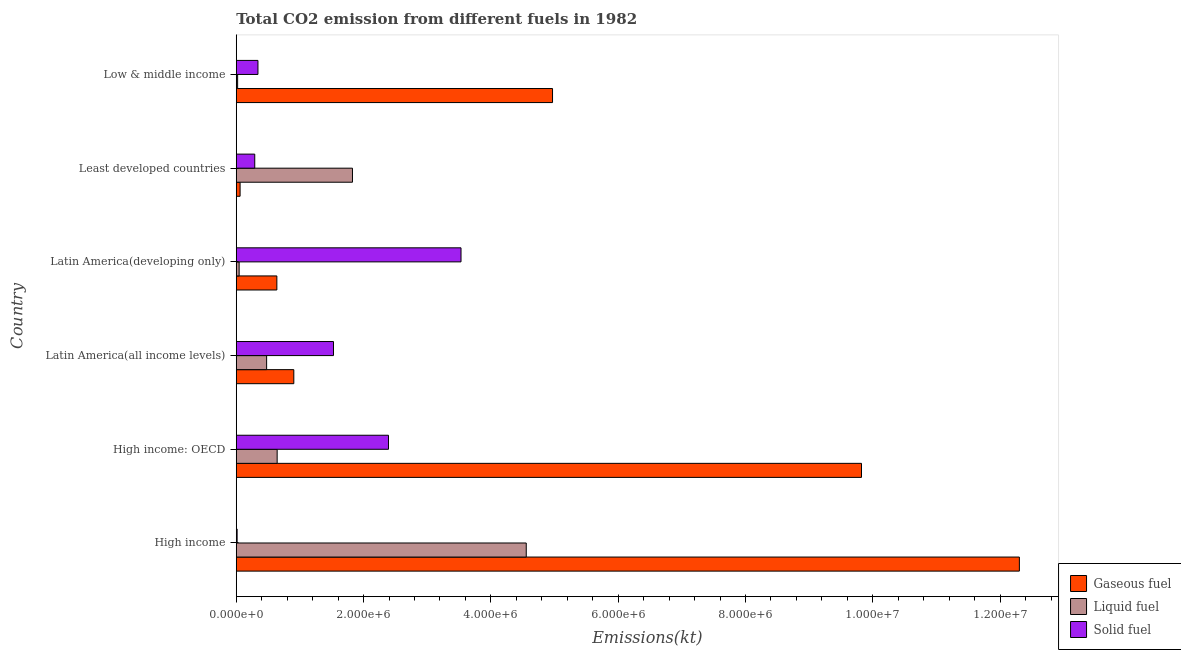How many different coloured bars are there?
Ensure brevity in your answer.  3. Are the number of bars per tick equal to the number of legend labels?
Provide a short and direct response. Yes. What is the label of the 4th group of bars from the top?
Ensure brevity in your answer.  Latin America(all income levels). In how many cases, is the number of bars for a given country not equal to the number of legend labels?
Keep it short and to the point. 0. What is the amount of co2 emissions from liquid fuel in High income: OECD?
Your answer should be very brief. 6.43e+05. Across all countries, what is the maximum amount of co2 emissions from liquid fuel?
Offer a very short reply. 4.56e+06. Across all countries, what is the minimum amount of co2 emissions from liquid fuel?
Offer a terse response. 2.16e+04. In which country was the amount of co2 emissions from solid fuel maximum?
Ensure brevity in your answer.  Latin America(developing only). In which country was the amount of co2 emissions from gaseous fuel minimum?
Give a very brief answer. Least developed countries. What is the total amount of co2 emissions from gaseous fuel in the graph?
Offer a very short reply. 2.87e+07. What is the difference between the amount of co2 emissions from liquid fuel in High income and that in High income: OECD?
Make the answer very short. 3.91e+06. What is the difference between the amount of co2 emissions from gaseous fuel in Least developed countries and the amount of co2 emissions from solid fuel in High income: OECD?
Offer a very short reply. -2.33e+06. What is the average amount of co2 emissions from solid fuel per country?
Your answer should be very brief. 1.35e+06. What is the difference between the amount of co2 emissions from gaseous fuel and amount of co2 emissions from solid fuel in Latin America(all income levels)?
Provide a succinct answer. -6.23e+05. In how many countries, is the amount of co2 emissions from solid fuel greater than 12000000 kt?
Your response must be concise. 0. What is the ratio of the amount of co2 emissions from gaseous fuel in High income: OECD to that in Latin America(all income levels)?
Keep it short and to the point. 10.86. Is the difference between the amount of co2 emissions from gaseous fuel in High income and Latin America(developing only) greater than the difference between the amount of co2 emissions from liquid fuel in High income and Latin America(developing only)?
Your answer should be very brief. Yes. What is the difference between the highest and the second highest amount of co2 emissions from gaseous fuel?
Offer a terse response. 2.48e+06. What is the difference between the highest and the lowest amount of co2 emissions from liquid fuel?
Give a very brief answer. 4.53e+06. Is the sum of the amount of co2 emissions from solid fuel in High income and Latin America(all income levels) greater than the maximum amount of co2 emissions from liquid fuel across all countries?
Ensure brevity in your answer.  No. What does the 1st bar from the top in Latin America(developing only) represents?
Provide a succinct answer. Solid fuel. What does the 3rd bar from the bottom in Low & middle income represents?
Your answer should be compact. Solid fuel. Is it the case that in every country, the sum of the amount of co2 emissions from gaseous fuel and amount of co2 emissions from liquid fuel is greater than the amount of co2 emissions from solid fuel?
Your answer should be very brief. No. What is the difference between two consecutive major ticks on the X-axis?
Make the answer very short. 2.00e+06. Where does the legend appear in the graph?
Provide a succinct answer. Bottom right. How many legend labels are there?
Your answer should be compact. 3. How are the legend labels stacked?
Offer a terse response. Vertical. What is the title of the graph?
Your response must be concise. Total CO2 emission from different fuels in 1982. Does "Interest" appear as one of the legend labels in the graph?
Your answer should be compact. No. What is the label or title of the X-axis?
Ensure brevity in your answer.  Emissions(kt). What is the label or title of the Y-axis?
Your answer should be very brief. Country. What is the Emissions(kt) in Gaseous fuel in High income?
Offer a terse response. 1.23e+07. What is the Emissions(kt) in Liquid fuel in High income?
Keep it short and to the point. 4.56e+06. What is the Emissions(kt) of Solid fuel in High income?
Give a very brief answer. 1.37e+04. What is the Emissions(kt) of Gaseous fuel in High income: OECD?
Offer a terse response. 9.82e+06. What is the Emissions(kt) in Liquid fuel in High income: OECD?
Ensure brevity in your answer.  6.43e+05. What is the Emissions(kt) in Solid fuel in High income: OECD?
Offer a very short reply. 2.39e+06. What is the Emissions(kt) of Gaseous fuel in Latin America(all income levels)?
Keep it short and to the point. 9.04e+05. What is the Emissions(kt) of Liquid fuel in Latin America(all income levels)?
Give a very brief answer. 4.77e+05. What is the Emissions(kt) in Solid fuel in Latin America(all income levels)?
Your answer should be compact. 1.53e+06. What is the Emissions(kt) of Gaseous fuel in Latin America(developing only)?
Your answer should be compact. 6.38e+05. What is the Emissions(kt) of Liquid fuel in Latin America(developing only)?
Give a very brief answer. 4.53e+04. What is the Emissions(kt) of Solid fuel in Latin America(developing only)?
Provide a short and direct response. 3.53e+06. What is the Emissions(kt) in Gaseous fuel in Least developed countries?
Offer a very short reply. 6.04e+04. What is the Emissions(kt) of Liquid fuel in Least developed countries?
Provide a succinct answer. 1.83e+06. What is the Emissions(kt) in Solid fuel in Least developed countries?
Make the answer very short. 2.91e+05. What is the Emissions(kt) in Gaseous fuel in Low & middle income?
Provide a short and direct response. 4.97e+06. What is the Emissions(kt) in Liquid fuel in Low & middle income?
Keep it short and to the point. 2.16e+04. What is the Emissions(kt) of Solid fuel in Low & middle income?
Offer a very short reply. 3.41e+05. Across all countries, what is the maximum Emissions(kt) in Gaseous fuel?
Keep it short and to the point. 1.23e+07. Across all countries, what is the maximum Emissions(kt) of Liquid fuel?
Offer a very short reply. 4.56e+06. Across all countries, what is the maximum Emissions(kt) of Solid fuel?
Your response must be concise. 3.53e+06. Across all countries, what is the minimum Emissions(kt) in Gaseous fuel?
Provide a succinct answer. 6.04e+04. Across all countries, what is the minimum Emissions(kt) in Liquid fuel?
Offer a terse response. 2.16e+04. Across all countries, what is the minimum Emissions(kt) in Solid fuel?
Your response must be concise. 1.37e+04. What is the total Emissions(kt) in Gaseous fuel in the graph?
Your answer should be very brief. 2.87e+07. What is the total Emissions(kt) of Liquid fuel in the graph?
Your response must be concise. 7.57e+06. What is the total Emissions(kt) in Solid fuel in the graph?
Give a very brief answer. 8.10e+06. What is the difference between the Emissions(kt) of Gaseous fuel in High income and that in High income: OECD?
Provide a short and direct response. 2.48e+06. What is the difference between the Emissions(kt) of Liquid fuel in High income and that in High income: OECD?
Provide a short and direct response. 3.91e+06. What is the difference between the Emissions(kt) of Solid fuel in High income and that in High income: OECD?
Make the answer very short. -2.38e+06. What is the difference between the Emissions(kt) of Gaseous fuel in High income and that in Latin America(all income levels)?
Ensure brevity in your answer.  1.14e+07. What is the difference between the Emissions(kt) in Liquid fuel in High income and that in Latin America(all income levels)?
Provide a short and direct response. 4.08e+06. What is the difference between the Emissions(kt) of Solid fuel in High income and that in Latin America(all income levels)?
Provide a short and direct response. -1.51e+06. What is the difference between the Emissions(kt) in Gaseous fuel in High income and that in Latin America(developing only)?
Keep it short and to the point. 1.17e+07. What is the difference between the Emissions(kt) in Liquid fuel in High income and that in Latin America(developing only)?
Your response must be concise. 4.51e+06. What is the difference between the Emissions(kt) of Solid fuel in High income and that in Latin America(developing only)?
Make the answer very short. -3.52e+06. What is the difference between the Emissions(kt) of Gaseous fuel in High income and that in Least developed countries?
Ensure brevity in your answer.  1.22e+07. What is the difference between the Emissions(kt) of Liquid fuel in High income and that in Least developed countries?
Offer a very short reply. 2.73e+06. What is the difference between the Emissions(kt) in Solid fuel in High income and that in Least developed countries?
Offer a very short reply. -2.77e+05. What is the difference between the Emissions(kt) of Gaseous fuel in High income and that in Low & middle income?
Offer a terse response. 7.33e+06. What is the difference between the Emissions(kt) of Liquid fuel in High income and that in Low & middle income?
Make the answer very short. 4.53e+06. What is the difference between the Emissions(kt) in Solid fuel in High income and that in Low & middle income?
Your answer should be compact. -3.27e+05. What is the difference between the Emissions(kt) of Gaseous fuel in High income: OECD and that in Latin America(all income levels)?
Provide a short and direct response. 8.92e+06. What is the difference between the Emissions(kt) of Liquid fuel in High income: OECD and that in Latin America(all income levels)?
Give a very brief answer. 1.65e+05. What is the difference between the Emissions(kt) in Solid fuel in High income: OECD and that in Latin America(all income levels)?
Provide a succinct answer. 8.64e+05. What is the difference between the Emissions(kt) of Gaseous fuel in High income: OECD and that in Latin America(developing only)?
Offer a terse response. 9.18e+06. What is the difference between the Emissions(kt) in Liquid fuel in High income: OECD and that in Latin America(developing only)?
Keep it short and to the point. 5.97e+05. What is the difference between the Emissions(kt) of Solid fuel in High income: OECD and that in Latin America(developing only)?
Keep it short and to the point. -1.14e+06. What is the difference between the Emissions(kt) in Gaseous fuel in High income: OECD and that in Least developed countries?
Your answer should be very brief. 9.76e+06. What is the difference between the Emissions(kt) in Liquid fuel in High income: OECD and that in Least developed countries?
Provide a succinct answer. -1.18e+06. What is the difference between the Emissions(kt) of Solid fuel in High income: OECD and that in Least developed countries?
Your answer should be compact. 2.10e+06. What is the difference between the Emissions(kt) in Gaseous fuel in High income: OECD and that in Low & middle income?
Your answer should be very brief. 4.85e+06. What is the difference between the Emissions(kt) of Liquid fuel in High income: OECD and that in Low & middle income?
Offer a terse response. 6.21e+05. What is the difference between the Emissions(kt) in Solid fuel in High income: OECD and that in Low & middle income?
Provide a succinct answer. 2.05e+06. What is the difference between the Emissions(kt) in Gaseous fuel in Latin America(all income levels) and that in Latin America(developing only)?
Provide a succinct answer. 2.66e+05. What is the difference between the Emissions(kt) of Liquid fuel in Latin America(all income levels) and that in Latin America(developing only)?
Give a very brief answer. 4.32e+05. What is the difference between the Emissions(kt) in Solid fuel in Latin America(all income levels) and that in Latin America(developing only)?
Offer a terse response. -2.00e+06. What is the difference between the Emissions(kt) in Gaseous fuel in Latin America(all income levels) and that in Least developed countries?
Your answer should be very brief. 8.44e+05. What is the difference between the Emissions(kt) in Liquid fuel in Latin America(all income levels) and that in Least developed countries?
Ensure brevity in your answer.  -1.35e+06. What is the difference between the Emissions(kt) in Solid fuel in Latin America(all income levels) and that in Least developed countries?
Your answer should be compact. 1.24e+06. What is the difference between the Emissions(kt) of Gaseous fuel in Latin America(all income levels) and that in Low & middle income?
Your response must be concise. -4.06e+06. What is the difference between the Emissions(kt) of Liquid fuel in Latin America(all income levels) and that in Low & middle income?
Your response must be concise. 4.56e+05. What is the difference between the Emissions(kt) of Solid fuel in Latin America(all income levels) and that in Low & middle income?
Provide a succinct answer. 1.19e+06. What is the difference between the Emissions(kt) of Gaseous fuel in Latin America(developing only) and that in Least developed countries?
Ensure brevity in your answer.  5.78e+05. What is the difference between the Emissions(kt) of Liquid fuel in Latin America(developing only) and that in Least developed countries?
Provide a succinct answer. -1.78e+06. What is the difference between the Emissions(kt) of Solid fuel in Latin America(developing only) and that in Least developed countries?
Make the answer very short. 3.24e+06. What is the difference between the Emissions(kt) of Gaseous fuel in Latin America(developing only) and that in Low & middle income?
Provide a short and direct response. -4.33e+06. What is the difference between the Emissions(kt) of Liquid fuel in Latin America(developing only) and that in Low & middle income?
Give a very brief answer. 2.37e+04. What is the difference between the Emissions(kt) in Solid fuel in Latin America(developing only) and that in Low & middle income?
Your response must be concise. 3.19e+06. What is the difference between the Emissions(kt) in Gaseous fuel in Least developed countries and that in Low & middle income?
Make the answer very short. -4.91e+06. What is the difference between the Emissions(kt) of Liquid fuel in Least developed countries and that in Low & middle income?
Your answer should be very brief. 1.80e+06. What is the difference between the Emissions(kt) of Solid fuel in Least developed countries and that in Low & middle income?
Offer a very short reply. -5.03e+04. What is the difference between the Emissions(kt) in Gaseous fuel in High income and the Emissions(kt) in Liquid fuel in High income: OECD?
Offer a very short reply. 1.17e+07. What is the difference between the Emissions(kt) of Gaseous fuel in High income and the Emissions(kt) of Solid fuel in High income: OECD?
Keep it short and to the point. 9.91e+06. What is the difference between the Emissions(kt) in Liquid fuel in High income and the Emissions(kt) in Solid fuel in High income: OECD?
Give a very brief answer. 2.16e+06. What is the difference between the Emissions(kt) in Gaseous fuel in High income and the Emissions(kt) in Liquid fuel in Latin America(all income levels)?
Give a very brief answer. 1.18e+07. What is the difference between the Emissions(kt) in Gaseous fuel in High income and the Emissions(kt) in Solid fuel in Latin America(all income levels)?
Make the answer very short. 1.08e+07. What is the difference between the Emissions(kt) of Liquid fuel in High income and the Emissions(kt) of Solid fuel in Latin America(all income levels)?
Make the answer very short. 3.03e+06. What is the difference between the Emissions(kt) of Gaseous fuel in High income and the Emissions(kt) of Liquid fuel in Latin America(developing only)?
Your response must be concise. 1.23e+07. What is the difference between the Emissions(kt) of Gaseous fuel in High income and the Emissions(kt) of Solid fuel in Latin America(developing only)?
Your response must be concise. 8.77e+06. What is the difference between the Emissions(kt) of Liquid fuel in High income and the Emissions(kt) of Solid fuel in Latin America(developing only)?
Ensure brevity in your answer.  1.02e+06. What is the difference between the Emissions(kt) in Gaseous fuel in High income and the Emissions(kt) in Liquid fuel in Least developed countries?
Provide a succinct answer. 1.05e+07. What is the difference between the Emissions(kt) of Gaseous fuel in High income and the Emissions(kt) of Solid fuel in Least developed countries?
Ensure brevity in your answer.  1.20e+07. What is the difference between the Emissions(kt) of Liquid fuel in High income and the Emissions(kt) of Solid fuel in Least developed countries?
Keep it short and to the point. 4.27e+06. What is the difference between the Emissions(kt) in Gaseous fuel in High income and the Emissions(kt) in Liquid fuel in Low & middle income?
Make the answer very short. 1.23e+07. What is the difference between the Emissions(kt) in Gaseous fuel in High income and the Emissions(kt) in Solid fuel in Low & middle income?
Offer a very short reply. 1.20e+07. What is the difference between the Emissions(kt) of Liquid fuel in High income and the Emissions(kt) of Solid fuel in Low & middle income?
Ensure brevity in your answer.  4.21e+06. What is the difference between the Emissions(kt) in Gaseous fuel in High income: OECD and the Emissions(kt) in Liquid fuel in Latin America(all income levels)?
Make the answer very short. 9.35e+06. What is the difference between the Emissions(kt) in Gaseous fuel in High income: OECD and the Emissions(kt) in Solid fuel in Latin America(all income levels)?
Provide a succinct answer. 8.30e+06. What is the difference between the Emissions(kt) of Liquid fuel in High income: OECD and the Emissions(kt) of Solid fuel in Latin America(all income levels)?
Offer a very short reply. -8.85e+05. What is the difference between the Emissions(kt) of Gaseous fuel in High income: OECD and the Emissions(kt) of Liquid fuel in Latin America(developing only)?
Provide a short and direct response. 9.78e+06. What is the difference between the Emissions(kt) in Gaseous fuel in High income: OECD and the Emissions(kt) in Solid fuel in Latin America(developing only)?
Your answer should be compact. 6.29e+06. What is the difference between the Emissions(kt) in Liquid fuel in High income: OECD and the Emissions(kt) in Solid fuel in Latin America(developing only)?
Keep it short and to the point. -2.89e+06. What is the difference between the Emissions(kt) of Gaseous fuel in High income: OECD and the Emissions(kt) of Liquid fuel in Least developed countries?
Provide a short and direct response. 8.00e+06. What is the difference between the Emissions(kt) of Gaseous fuel in High income: OECD and the Emissions(kt) of Solid fuel in Least developed countries?
Offer a terse response. 9.53e+06. What is the difference between the Emissions(kt) of Liquid fuel in High income: OECD and the Emissions(kt) of Solid fuel in Least developed countries?
Keep it short and to the point. 3.52e+05. What is the difference between the Emissions(kt) of Gaseous fuel in High income: OECD and the Emissions(kt) of Liquid fuel in Low & middle income?
Give a very brief answer. 9.80e+06. What is the difference between the Emissions(kt) of Gaseous fuel in High income: OECD and the Emissions(kt) of Solid fuel in Low & middle income?
Provide a succinct answer. 9.48e+06. What is the difference between the Emissions(kt) of Liquid fuel in High income: OECD and the Emissions(kt) of Solid fuel in Low & middle income?
Give a very brief answer. 3.02e+05. What is the difference between the Emissions(kt) in Gaseous fuel in Latin America(all income levels) and the Emissions(kt) in Liquid fuel in Latin America(developing only)?
Your answer should be very brief. 8.59e+05. What is the difference between the Emissions(kt) in Gaseous fuel in Latin America(all income levels) and the Emissions(kt) in Solid fuel in Latin America(developing only)?
Ensure brevity in your answer.  -2.63e+06. What is the difference between the Emissions(kt) of Liquid fuel in Latin America(all income levels) and the Emissions(kt) of Solid fuel in Latin America(developing only)?
Provide a succinct answer. -3.05e+06. What is the difference between the Emissions(kt) of Gaseous fuel in Latin America(all income levels) and the Emissions(kt) of Liquid fuel in Least developed countries?
Your answer should be very brief. -9.22e+05. What is the difference between the Emissions(kt) of Gaseous fuel in Latin America(all income levels) and the Emissions(kt) of Solid fuel in Least developed countries?
Your response must be concise. 6.14e+05. What is the difference between the Emissions(kt) of Liquid fuel in Latin America(all income levels) and the Emissions(kt) of Solid fuel in Least developed countries?
Your answer should be compact. 1.87e+05. What is the difference between the Emissions(kt) in Gaseous fuel in Latin America(all income levels) and the Emissions(kt) in Liquid fuel in Low & middle income?
Give a very brief answer. 8.83e+05. What is the difference between the Emissions(kt) of Gaseous fuel in Latin America(all income levels) and the Emissions(kt) of Solid fuel in Low & middle income?
Your response must be concise. 5.63e+05. What is the difference between the Emissions(kt) in Liquid fuel in Latin America(all income levels) and the Emissions(kt) in Solid fuel in Low & middle income?
Your answer should be compact. 1.36e+05. What is the difference between the Emissions(kt) of Gaseous fuel in Latin America(developing only) and the Emissions(kt) of Liquid fuel in Least developed countries?
Your response must be concise. -1.19e+06. What is the difference between the Emissions(kt) in Gaseous fuel in Latin America(developing only) and the Emissions(kt) in Solid fuel in Least developed countries?
Your answer should be very brief. 3.47e+05. What is the difference between the Emissions(kt) of Liquid fuel in Latin America(developing only) and the Emissions(kt) of Solid fuel in Least developed countries?
Your answer should be compact. -2.45e+05. What is the difference between the Emissions(kt) in Gaseous fuel in Latin America(developing only) and the Emissions(kt) in Liquid fuel in Low & middle income?
Keep it short and to the point. 6.16e+05. What is the difference between the Emissions(kt) in Gaseous fuel in Latin America(developing only) and the Emissions(kt) in Solid fuel in Low & middle income?
Provide a succinct answer. 2.97e+05. What is the difference between the Emissions(kt) of Liquid fuel in Latin America(developing only) and the Emissions(kt) of Solid fuel in Low & middle income?
Give a very brief answer. -2.96e+05. What is the difference between the Emissions(kt) in Gaseous fuel in Least developed countries and the Emissions(kt) in Liquid fuel in Low & middle income?
Your answer should be very brief. 3.88e+04. What is the difference between the Emissions(kt) of Gaseous fuel in Least developed countries and the Emissions(kt) of Solid fuel in Low & middle income?
Your answer should be compact. -2.81e+05. What is the difference between the Emissions(kt) of Liquid fuel in Least developed countries and the Emissions(kt) of Solid fuel in Low & middle income?
Keep it short and to the point. 1.48e+06. What is the average Emissions(kt) in Gaseous fuel per country?
Keep it short and to the point. 4.78e+06. What is the average Emissions(kt) of Liquid fuel per country?
Give a very brief answer. 1.26e+06. What is the average Emissions(kt) of Solid fuel per country?
Ensure brevity in your answer.  1.35e+06. What is the difference between the Emissions(kt) of Gaseous fuel and Emissions(kt) of Liquid fuel in High income?
Offer a very short reply. 7.75e+06. What is the difference between the Emissions(kt) in Gaseous fuel and Emissions(kt) in Solid fuel in High income?
Keep it short and to the point. 1.23e+07. What is the difference between the Emissions(kt) of Liquid fuel and Emissions(kt) of Solid fuel in High income?
Offer a terse response. 4.54e+06. What is the difference between the Emissions(kt) in Gaseous fuel and Emissions(kt) in Liquid fuel in High income: OECD?
Your answer should be compact. 9.18e+06. What is the difference between the Emissions(kt) in Gaseous fuel and Emissions(kt) in Solid fuel in High income: OECD?
Offer a very short reply. 7.43e+06. What is the difference between the Emissions(kt) of Liquid fuel and Emissions(kt) of Solid fuel in High income: OECD?
Your answer should be very brief. -1.75e+06. What is the difference between the Emissions(kt) in Gaseous fuel and Emissions(kt) in Liquid fuel in Latin America(all income levels)?
Provide a succinct answer. 4.27e+05. What is the difference between the Emissions(kt) in Gaseous fuel and Emissions(kt) in Solid fuel in Latin America(all income levels)?
Offer a terse response. -6.23e+05. What is the difference between the Emissions(kt) of Liquid fuel and Emissions(kt) of Solid fuel in Latin America(all income levels)?
Offer a very short reply. -1.05e+06. What is the difference between the Emissions(kt) of Gaseous fuel and Emissions(kt) of Liquid fuel in Latin America(developing only)?
Your answer should be compact. 5.93e+05. What is the difference between the Emissions(kt) in Gaseous fuel and Emissions(kt) in Solid fuel in Latin America(developing only)?
Ensure brevity in your answer.  -2.89e+06. What is the difference between the Emissions(kt) in Liquid fuel and Emissions(kt) in Solid fuel in Latin America(developing only)?
Your response must be concise. -3.49e+06. What is the difference between the Emissions(kt) of Gaseous fuel and Emissions(kt) of Liquid fuel in Least developed countries?
Provide a succinct answer. -1.77e+06. What is the difference between the Emissions(kt) in Gaseous fuel and Emissions(kt) in Solid fuel in Least developed countries?
Offer a terse response. -2.30e+05. What is the difference between the Emissions(kt) of Liquid fuel and Emissions(kt) of Solid fuel in Least developed countries?
Ensure brevity in your answer.  1.54e+06. What is the difference between the Emissions(kt) of Gaseous fuel and Emissions(kt) of Liquid fuel in Low & middle income?
Your answer should be very brief. 4.95e+06. What is the difference between the Emissions(kt) of Gaseous fuel and Emissions(kt) of Solid fuel in Low & middle income?
Give a very brief answer. 4.63e+06. What is the difference between the Emissions(kt) in Liquid fuel and Emissions(kt) in Solid fuel in Low & middle income?
Your response must be concise. -3.19e+05. What is the ratio of the Emissions(kt) of Gaseous fuel in High income to that in High income: OECD?
Provide a succinct answer. 1.25. What is the ratio of the Emissions(kt) of Liquid fuel in High income to that in High income: OECD?
Your answer should be compact. 7.09. What is the ratio of the Emissions(kt) in Solid fuel in High income to that in High income: OECD?
Offer a terse response. 0.01. What is the ratio of the Emissions(kt) of Gaseous fuel in High income to that in Latin America(all income levels)?
Provide a short and direct response. 13.61. What is the ratio of the Emissions(kt) in Liquid fuel in High income to that in Latin America(all income levels)?
Provide a succinct answer. 9.55. What is the ratio of the Emissions(kt) of Solid fuel in High income to that in Latin America(all income levels)?
Provide a succinct answer. 0.01. What is the ratio of the Emissions(kt) of Gaseous fuel in High income to that in Latin America(developing only)?
Provide a succinct answer. 19.29. What is the ratio of the Emissions(kt) of Liquid fuel in High income to that in Latin America(developing only)?
Offer a terse response. 100.6. What is the ratio of the Emissions(kt) of Solid fuel in High income to that in Latin America(developing only)?
Your answer should be compact. 0. What is the ratio of the Emissions(kt) in Gaseous fuel in High income to that in Least developed countries?
Offer a terse response. 203.74. What is the ratio of the Emissions(kt) of Liquid fuel in High income to that in Least developed countries?
Offer a very short reply. 2.5. What is the ratio of the Emissions(kt) in Solid fuel in High income to that in Least developed countries?
Provide a succinct answer. 0.05. What is the ratio of the Emissions(kt) of Gaseous fuel in High income to that in Low & middle income?
Keep it short and to the point. 2.48. What is the ratio of the Emissions(kt) in Liquid fuel in High income to that in Low & middle income?
Provide a short and direct response. 210.8. What is the ratio of the Emissions(kt) of Solid fuel in High income to that in Low & middle income?
Your answer should be compact. 0.04. What is the ratio of the Emissions(kt) of Gaseous fuel in High income: OECD to that in Latin America(all income levels)?
Provide a succinct answer. 10.86. What is the ratio of the Emissions(kt) of Liquid fuel in High income: OECD to that in Latin America(all income levels)?
Provide a succinct answer. 1.35. What is the ratio of the Emissions(kt) in Solid fuel in High income: OECD to that in Latin America(all income levels)?
Keep it short and to the point. 1.57. What is the ratio of the Emissions(kt) in Gaseous fuel in High income: OECD to that in Latin America(developing only)?
Provide a short and direct response. 15.4. What is the ratio of the Emissions(kt) of Liquid fuel in High income: OECD to that in Latin America(developing only)?
Your answer should be compact. 14.19. What is the ratio of the Emissions(kt) in Solid fuel in High income: OECD to that in Latin America(developing only)?
Your response must be concise. 0.68. What is the ratio of the Emissions(kt) of Gaseous fuel in High income: OECD to that in Least developed countries?
Provide a short and direct response. 162.67. What is the ratio of the Emissions(kt) of Liquid fuel in High income: OECD to that in Least developed countries?
Make the answer very short. 0.35. What is the ratio of the Emissions(kt) in Solid fuel in High income: OECD to that in Least developed countries?
Give a very brief answer. 8.23. What is the ratio of the Emissions(kt) in Gaseous fuel in High income: OECD to that in Low & middle income?
Provide a succinct answer. 1.98. What is the ratio of the Emissions(kt) of Liquid fuel in High income: OECD to that in Low & middle income?
Your response must be concise. 29.74. What is the ratio of the Emissions(kt) in Solid fuel in High income: OECD to that in Low & middle income?
Provide a short and direct response. 7.01. What is the ratio of the Emissions(kt) of Gaseous fuel in Latin America(all income levels) to that in Latin America(developing only)?
Give a very brief answer. 1.42. What is the ratio of the Emissions(kt) of Liquid fuel in Latin America(all income levels) to that in Latin America(developing only)?
Your answer should be very brief. 10.54. What is the ratio of the Emissions(kt) of Solid fuel in Latin America(all income levels) to that in Latin America(developing only)?
Your answer should be very brief. 0.43. What is the ratio of the Emissions(kt) in Gaseous fuel in Latin America(all income levels) to that in Least developed countries?
Your answer should be compact. 14.98. What is the ratio of the Emissions(kt) in Liquid fuel in Latin America(all income levels) to that in Least developed countries?
Ensure brevity in your answer.  0.26. What is the ratio of the Emissions(kt) in Solid fuel in Latin America(all income levels) to that in Least developed countries?
Make the answer very short. 5.26. What is the ratio of the Emissions(kt) in Gaseous fuel in Latin America(all income levels) to that in Low & middle income?
Offer a terse response. 0.18. What is the ratio of the Emissions(kt) of Liquid fuel in Latin America(all income levels) to that in Low & middle income?
Offer a terse response. 22.08. What is the ratio of the Emissions(kt) of Solid fuel in Latin America(all income levels) to that in Low & middle income?
Offer a very short reply. 4.48. What is the ratio of the Emissions(kt) of Gaseous fuel in Latin America(developing only) to that in Least developed countries?
Provide a short and direct response. 10.56. What is the ratio of the Emissions(kt) in Liquid fuel in Latin America(developing only) to that in Least developed countries?
Offer a very short reply. 0.02. What is the ratio of the Emissions(kt) in Solid fuel in Latin America(developing only) to that in Least developed countries?
Ensure brevity in your answer.  12.15. What is the ratio of the Emissions(kt) of Gaseous fuel in Latin America(developing only) to that in Low & middle income?
Offer a terse response. 0.13. What is the ratio of the Emissions(kt) in Liquid fuel in Latin America(developing only) to that in Low & middle income?
Your response must be concise. 2.1. What is the ratio of the Emissions(kt) in Solid fuel in Latin America(developing only) to that in Low & middle income?
Give a very brief answer. 10.36. What is the ratio of the Emissions(kt) in Gaseous fuel in Least developed countries to that in Low & middle income?
Keep it short and to the point. 0.01. What is the ratio of the Emissions(kt) in Liquid fuel in Least developed countries to that in Low & middle income?
Offer a very short reply. 84.48. What is the ratio of the Emissions(kt) in Solid fuel in Least developed countries to that in Low & middle income?
Ensure brevity in your answer.  0.85. What is the difference between the highest and the second highest Emissions(kt) of Gaseous fuel?
Provide a succinct answer. 2.48e+06. What is the difference between the highest and the second highest Emissions(kt) of Liquid fuel?
Make the answer very short. 2.73e+06. What is the difference between the highest and the second highest Emissions(kt) in Solid fuel?
Offer a terse response. 1.14e+06. What is the difference between the highest and the lowest Emissions(kt) in Gaseous fuel?
Offer a very short reply. 1.22e+07. What is the difference between the highest and the lowest Emissions(kt) in Liquid fuel?
Give a very brief answer. 4.53e+06. What is the difference between the highest and the lowest Emissions(kt) in Solid fuel?
Your response must be concise. 3.52e+06. 